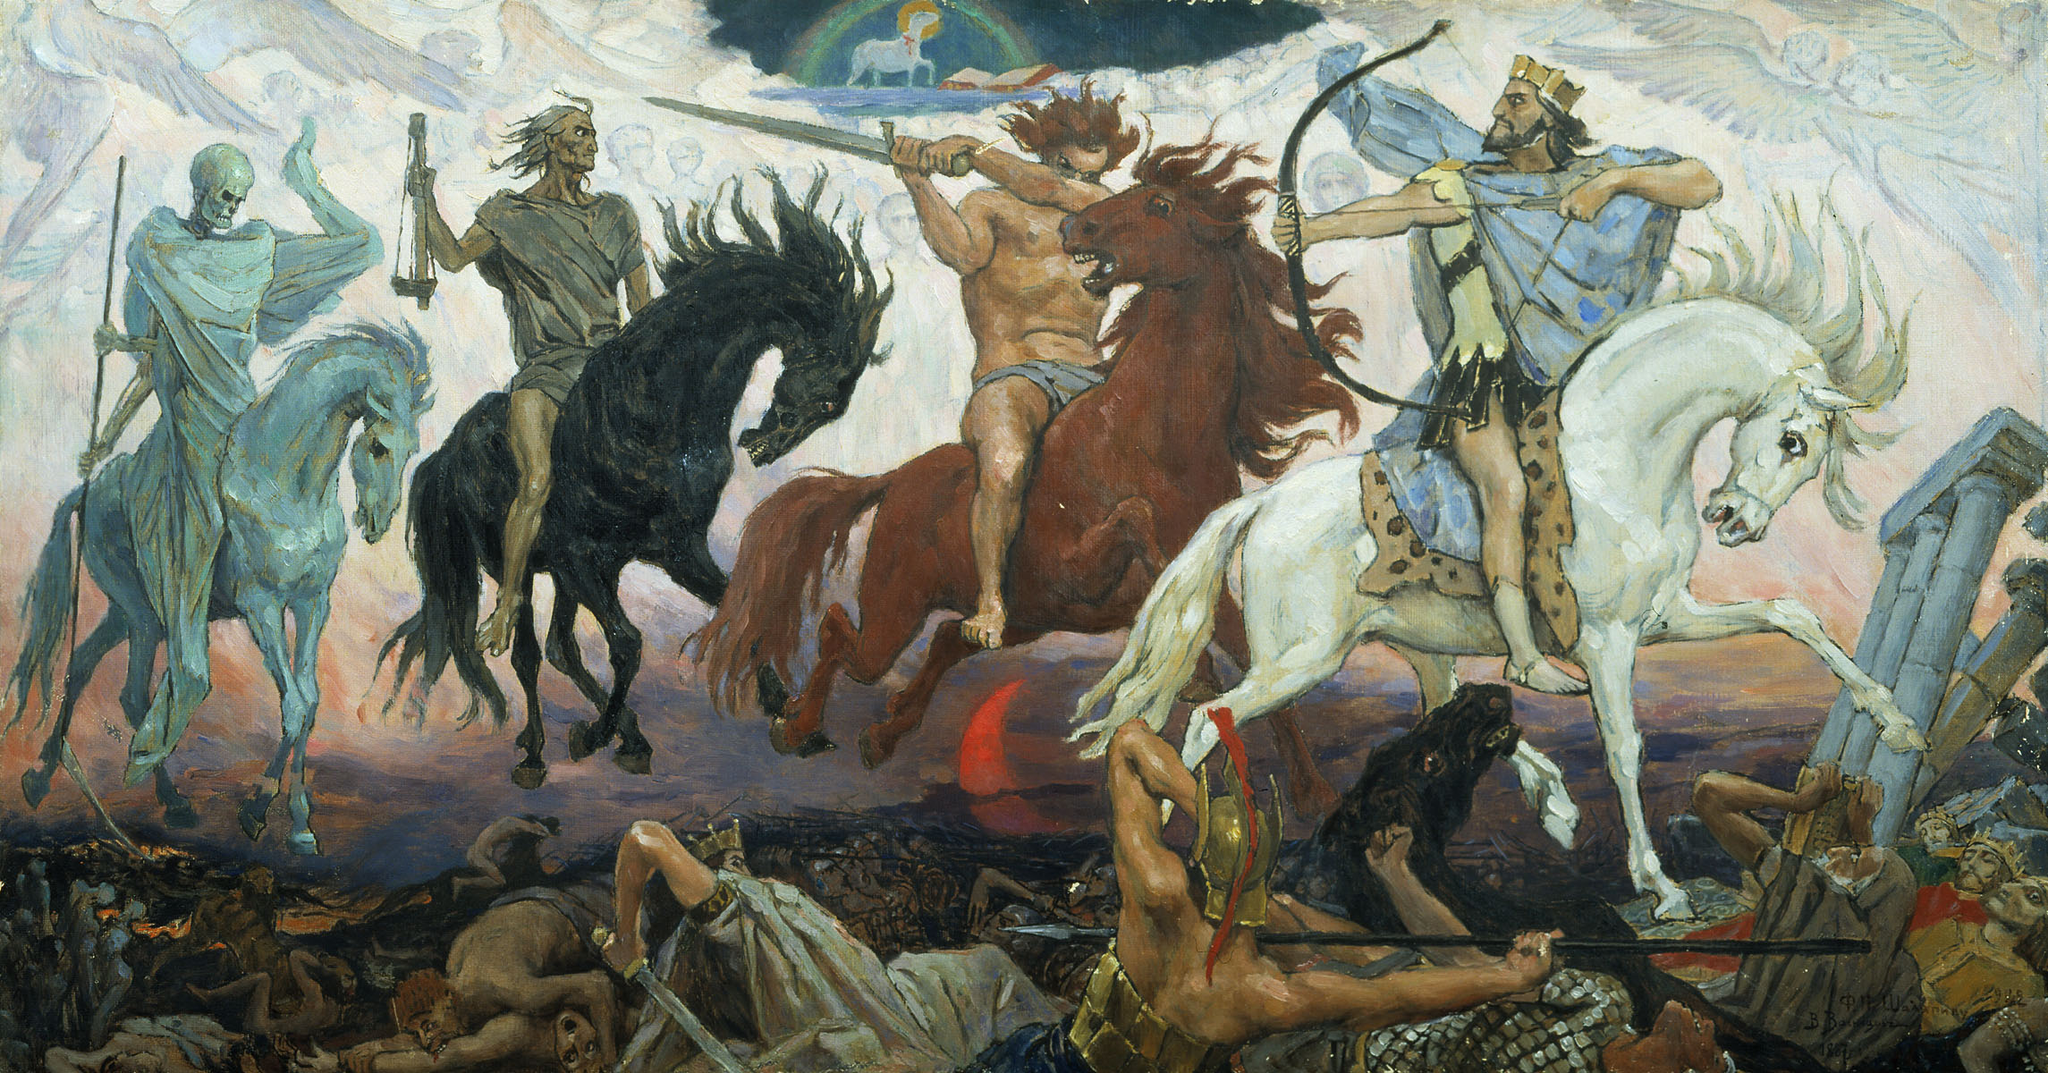Write a detailed description of the given image.
 The image portrays a dramatic battle scene, teeming with figures on horseback engaged in combat. The art style harks back to the Baroque period, characterized by its dynamic composition and dramatic lighting. The color palette is dominated by earth tones, punctuated with accents of red and blue. This artwork falls under the genre of history painting, which typically depicts historical events or figures. The figures themselves are in various poses, adding to the dynamism and intensity of the scene. The overall composition and the use of light and shadow create a sense of depth and movement, drawing the viewer into the heart of the battle. 